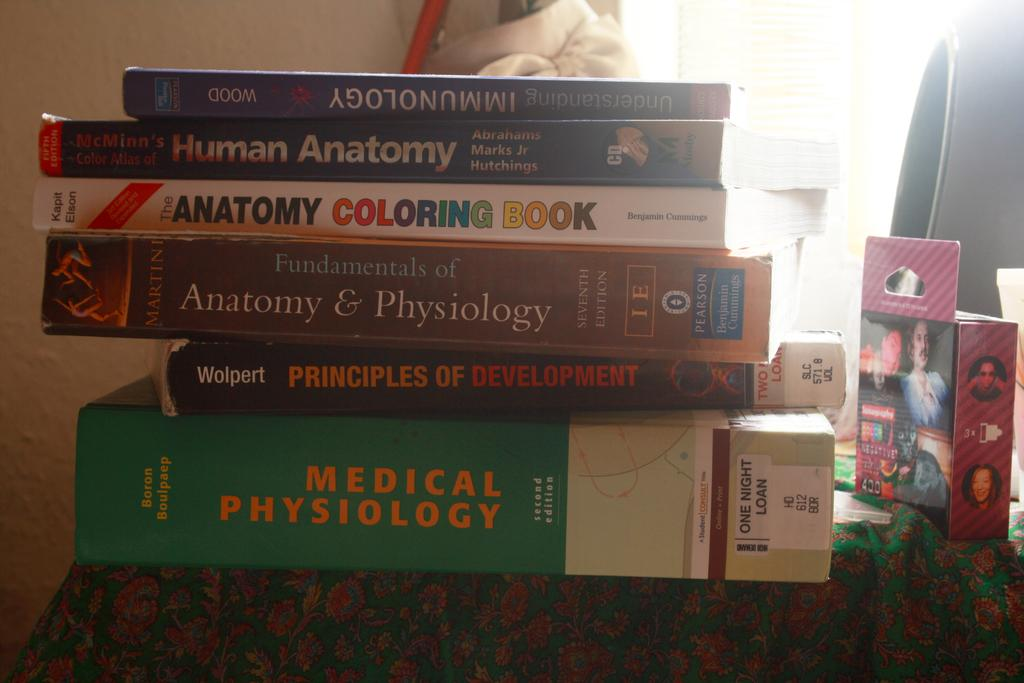<image>
Give a short and clear explanation of the subsequent image. A stack of books including Medical Physiology are on a green table cloth. 